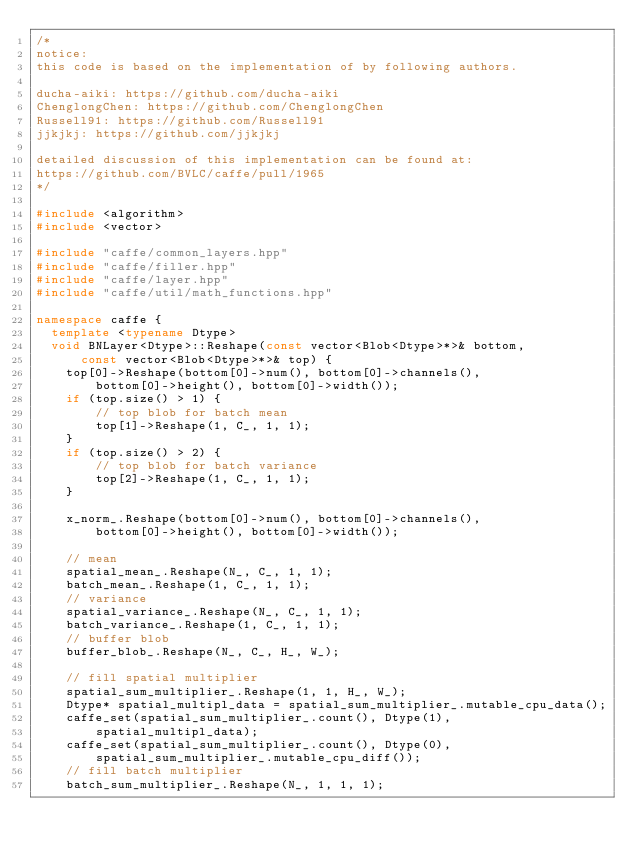Convert code to text. <code><loc_0><loc_0><loc_500><loc_500><_C++_>/*
notice:
this code is based on the implementation of by following authors.

ducha-aiki: https://github.com/ducha-aiki
ChenglongChen: https://github.com/ChenglongChen
Russell91: https://github.com/Russell91
jjkjkj: https://github.com/jjkjkj

detailed discussion of this implementation can be found at:
https://github.com/BVLC/caffe/pull/1965
*/

#include <algorithm>
#include <vector>

#include "caffe/common_layers.hpp"
#include "caffe/filler.hpp"
#include "caffe/layer.hpp"
#include "caffe/util/math_functions.hpp"

namespace caffe {
  template <typename Dtype>
  void BNLayer<Dtype>::Reshape(const vector<Blob<Dtype>*>& bottom,
      const vector<Blob<Dtype>*>& top) {
    top[0]->Reshape(bottom[0]->num(), bottom[0]->channels(),
        bottom[0]->height(), bottom[0]->width());
    if (top.size() > 1) {
        // top blob for batch mean
        top[1]->Reshape(1, C_, 1, 1);
    }
    if (top.size() > 2) {
        // top blob for batch variance
        top[2]->Reshape(1, C_, 1, 1);
    }

    x_norm_.Reshape(bottom[0]->num(), bottom[0]->channels(),
        bottom[0]->height(), bottom[0]->width());

    // mean
    spatial_mean_.Reshape(N_, C_, 1, 1);
    batch_mean_.Reshape(1, C_, 1, 1);
    // variance
    spatial_variance_.Reshape(N_, C_, 1, 1);
    batch_variance_.Reshape(1, C_, 1, 1);
    // buffer blob
    buffer_blob_.Reshape(N_, C_, H_, W_);

    // fill spatial multiplier
    spatial_sum_multiplier_.Reshape(1, 1, H_, W_);
    Dtype* spatial_multipl_data = spatial_sum_multiplier_.mutable_cpu_data();
    caffe_set(spatial_sum_multiplier_.count(), Dtype(1),
        spatial_multipl_data);
    caffe_set(spatial_sum_multiplier_.count(), Dtype(0),
        spatial_sum_multiplier_.mutable_cpu_diff());
    // fill batch multiplier
    batch_sum_multiplier_.Reshape(N_, 1, 1, 1);</code> 